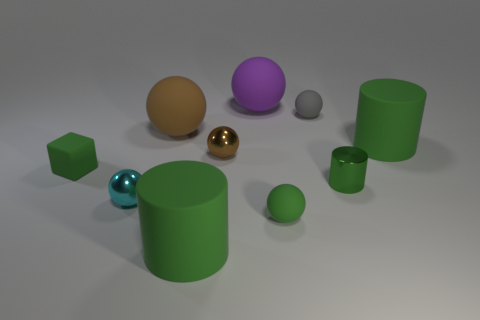What is the material of the gray sphere to the right of the shiny object that is to the left of the brown rubber object?
Provide a succinct answer. Rubber. Do the large green matte thing that is behind the small block and the small gray thing have the same shape?
Offer a very short reply. No. What color is the cube that is made of the same material as the big brown thing?
Provide a succinct answer. Green. What material is the tiny cyan sphere on the right side of the tiny green cube?
Provide a succinct answer. Metal. There is a small brown thing; is it the same shape as the large green matte thing to the left of the gray object?
Give a very brief answer. No. What is the sphere that is both to the left of the brown shiny sphere and in front of the large brown ball made of?
Keep it short and to the point. Metal. There is a metal cylinder that is the same size as the green block; what color is it?
Offer a very short reply. Green. Are the tiny brown thing and the big cylinder that is in front of the matte cube made of the same material?
Your answer should be compact. No. What number of other things are the same size as the green ball?
Keep it short and to the point. 5. Is there a large brown thing that is right of the metallic thing that is behind the small green rubber object that is behind the small green matte sphere?
Keep it short and to the point. No. 